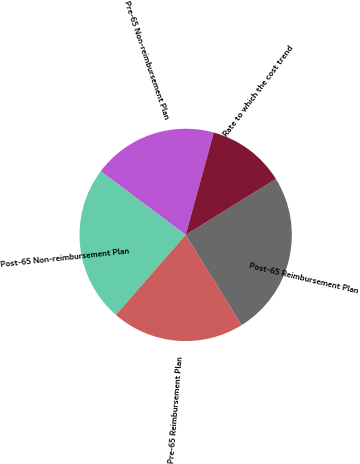<chart> <loc_0><loc_0><loc_500><loc_500><pie_chart><fcel>Pre-65 Non-reimbursement Plan<fcel>Post-65 Non-reimbursement Plan<fcel>Pre-65 Reimbursement Plan<fcel>Post-65 Reimbursement Plan<fcel>Rate to which the cost trend<nl><fcel>19.05%<fcel>23.81%<fcel>20.24%<fcel>25.0%<fcel>11.9%<nl></chart> 